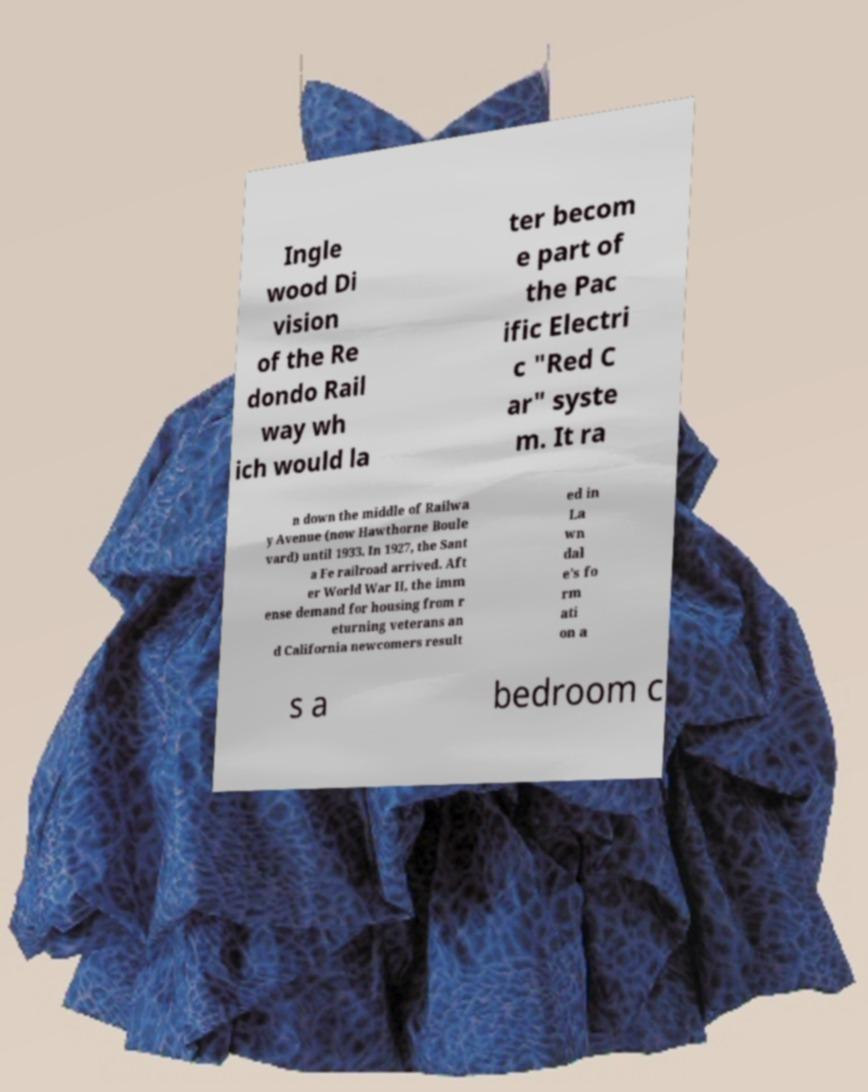For documentation purposes, I need the text within this image transcribed. Could you provide that? Ingle wood Di vision of the Re dondo Rail way wh ich would la ter becom e part of the Pac ific Electri c "Red C ar" syste m. It ra n down the middle of Railwa y Avenue (now Hawthorne Boule vard) until 1933. In 1927, the Sant a Fe railroad arrived. Aft er World War II, the imm ense demand for housing from r eturning veterans an d California newcomers result ed in La wn dal e's fo rm ati on a s a bedroom c 